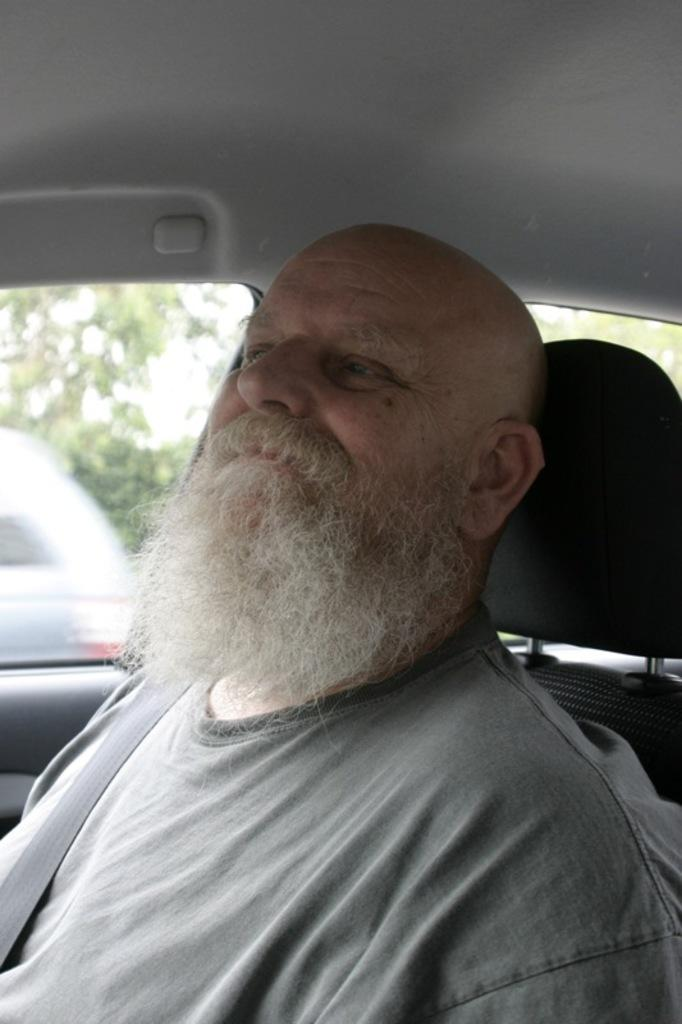What is the person in the image doing? The person is sitting in a car. What type of window is present on the car? The car has a glass window. What can be seen through the glass window? Vehicles are visible through the glass window. What is the condition of the sky in the image? The sky is clear and visible in the image. Is there a lock on the car door in the image? There is no mention of a lock on the car door in the provided facts, so we cannot determine its presence from the image. 